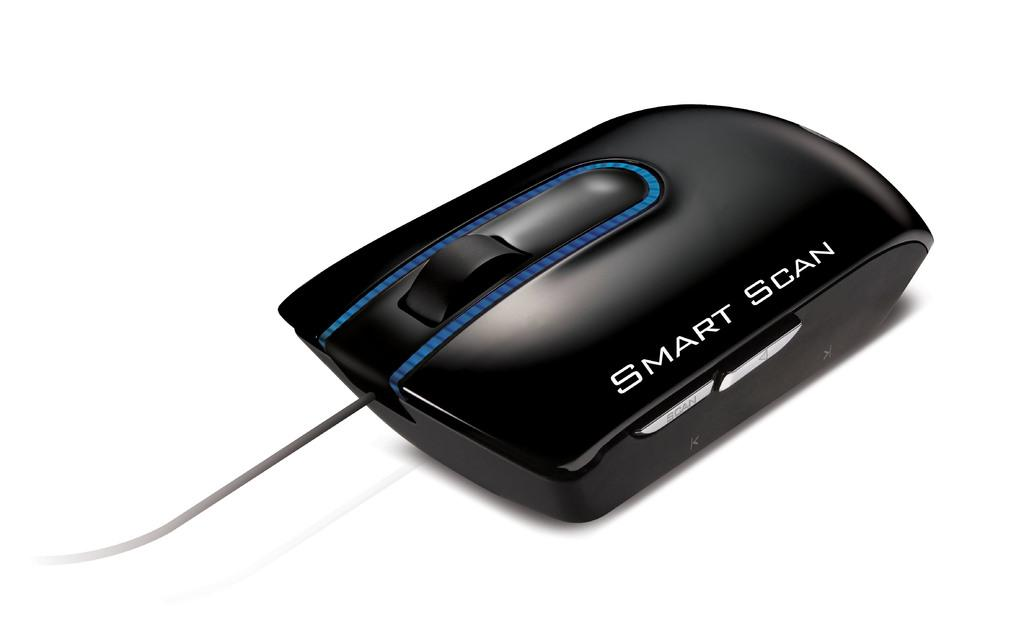What type of animal is in the image? There is a black color mouse in the image. What is located in the middle of the image? There is a scroll button in the middle of the image. What else can be seen in the image? There is a wire visible in the image. Can you see the mouse smiling in the image? There is no indication of the mouse smiling in the image, as it is a mouse and not capable of facial expressions like humans. 